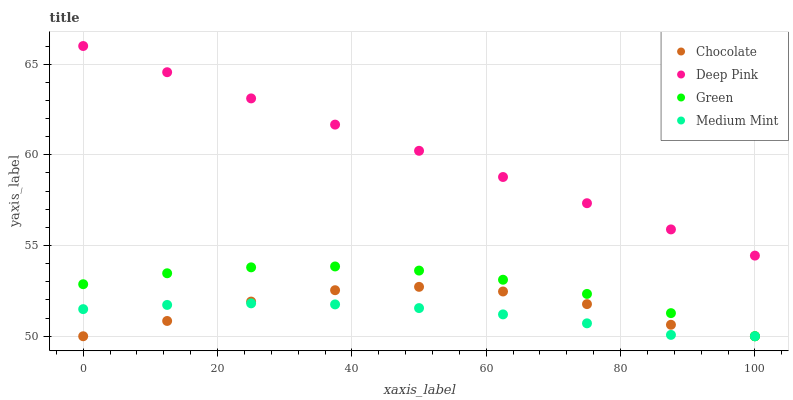Does Medium Mint have the minimum area under the curve?
Answer yes or no. Yes. Does Deep Pink have the maximum area under the curve?
Answer yes or no. Yes. Does Green have the minimum area under the curve?
Answer yes or no. No. Does Green have the maximum area under the curve?
Answer yes or no. No. Is Deep Pink the smoothest?
Answer yes or no. Yes. Is Chocolate the roughest?
Answer yes or no. Yes. Is Green the smoothest?
Answer yes or no. No. Is Green the roughest?
Answer yes or no. No. Does Medium Mint have the lowest value?
Answer yes or no. Yes. Does Deep Pink have the lowest value?
Answer yes or no. No. Does Deep Pink have the highest value?
Answer yes or no. Yes. Does Green have the highest value?
Answer yes or no. No. Is Chocolate less than Deep Pink?
Answer yes or no. Yes. Is Deep Pink greater than Chocolate?
Answer yes or no. Yes. Does Medium Mint intersect Chocolate?
Answer yes or no. Yes. Is Medium Mint less than Chocolate?
Answer yes or no. No. Is Medium Mint greater than Chocolate?
Answer yes or no. No. Does Chocolate intersect Deep Pink?
Answer yes or no. No. 